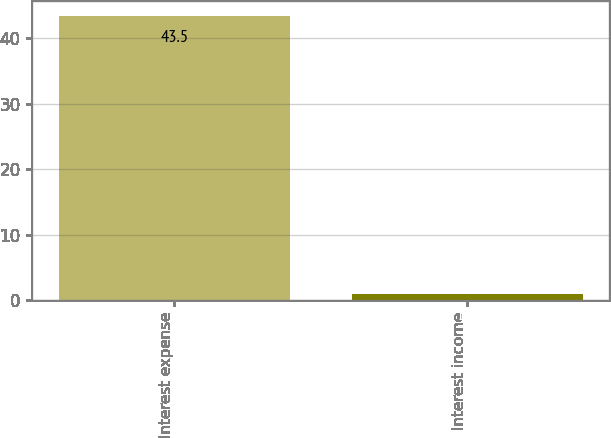<chart> <loc_0><loc_0><loc_500><loc_500><bar_chart><fcel>Interest expense<fcel>Interest income<nl><fcel>43.5<fcel>1<nl></chart> 